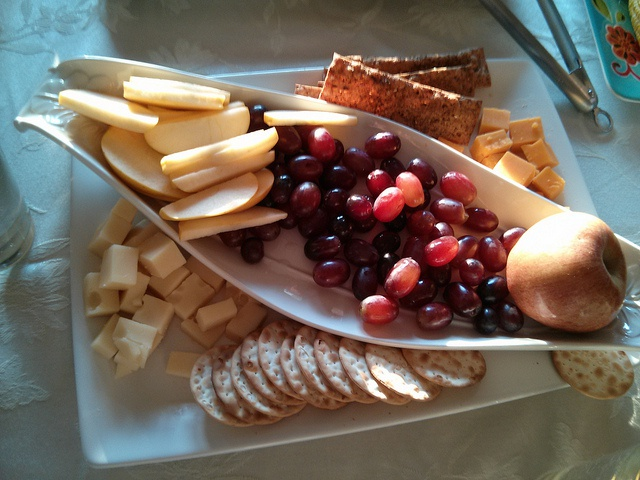Describe the objects in this image and their specific colors. I can see dining table in gray, maroon, and black tones, apple in gray, brown, ivory, and tan tones, apple in gray, maroon, ivory, and brown tones, and cup in gray and teal tones in this image. 